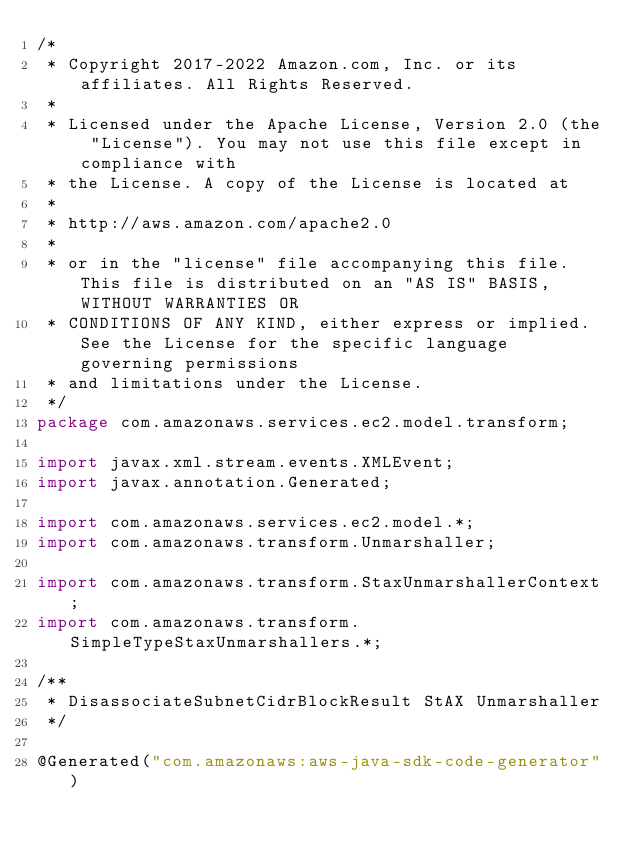<code> <loc_0><loc_0><loc_500><loc_500><_Java_>/*
 * Copyright 2017-2022 Amazon.com, Inc. or its affiliates. All Rights Reserved.
 * 
 * Licensed under the Apache License, Version 2.0 (the "License"). You may not use this file except in compliance with
 * the License. A copy of the License is located at
 * 
 * http://aws.amazon.com/apache2.0
 * 
 * or in the "license" file accompanying this file. This file is distributed on an "AS IS" BASIS, WITHOUT WARRANTIES OR
 * CONDITIONS OF ANY KIND, either express or implied. See the License for the specific language governing permissions
 * and limitations under the License.
 */
package com.amazonaws.services.ec2.model.transform;

import javax.xml.stream.events.XMLEvent;
import javax.annotation.Generated;

import com.amazonaws.services.ec2.model.*;
import com.amazonaws.transform.Unmarshaller;

import com.amazonaws.transform.StaxUnmarshallerContext;
import com.amazonaws.transform.SimpleTypeStaxUnmarshallers.*;

/**
 * DisassociateSubnetCidrBlockResult StAX Unmarshaller
 */

@Generated("com.amazonaws:aws-java-sdk-code-generator")</code> 